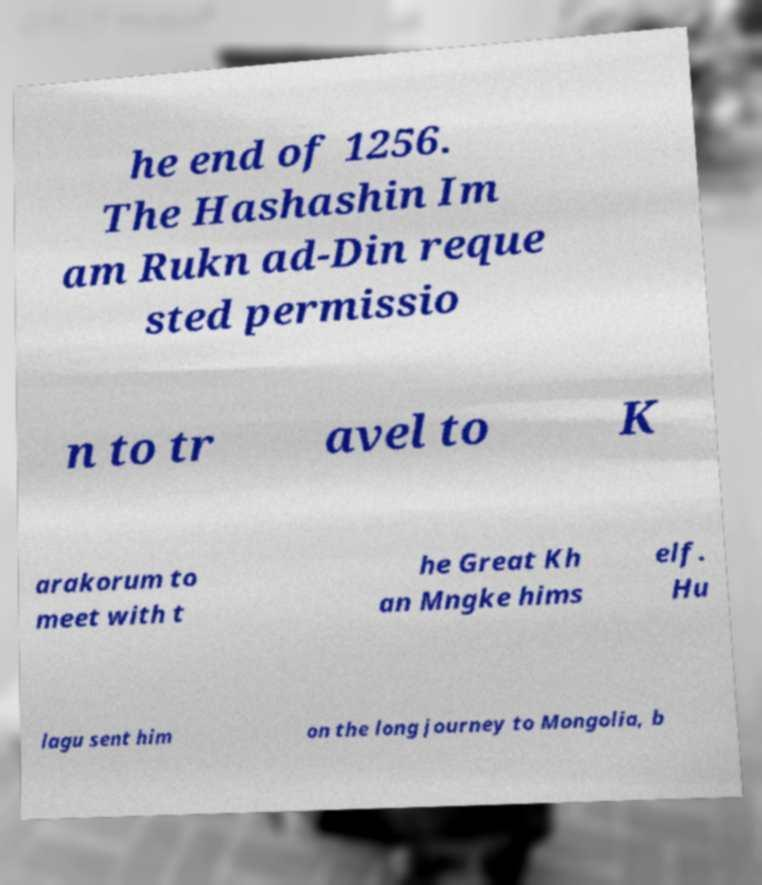Can you read and provide the text displayed in the image?This photo seems to have some interesting text. Can you extract and type it out for me? he end of 1256. The Hashashin Im am Rukn ad-Din reque sted permissio n to tr avel to K arakorum to meet with t he Great Kh an Mngke hims elf. Hu lagu sent him on the long journey to Mongolia, b 